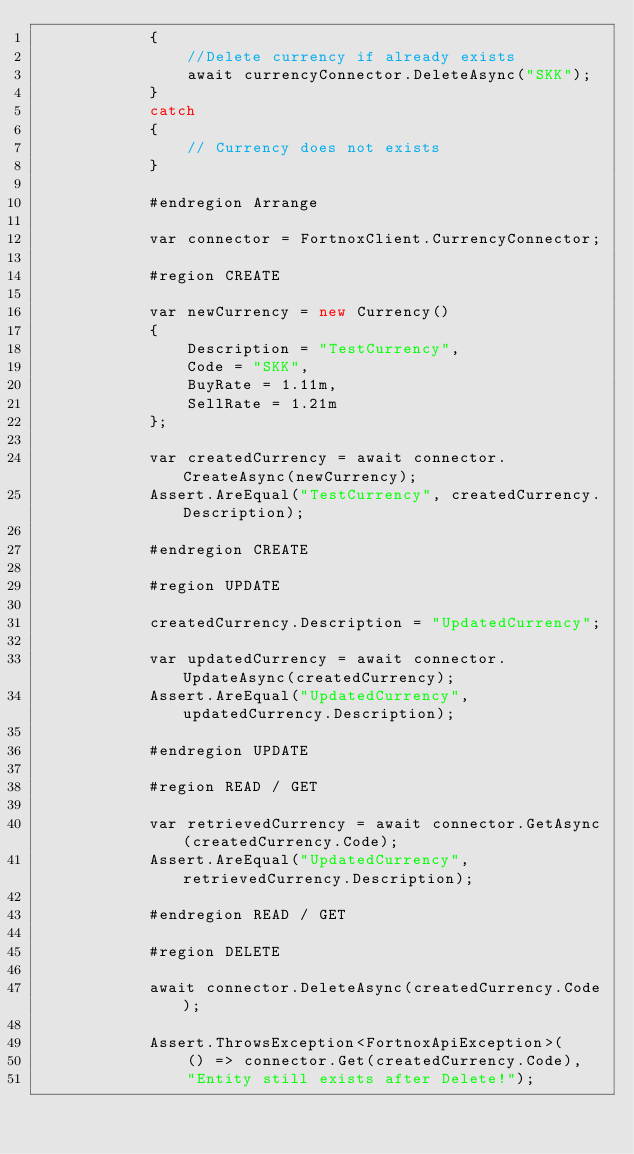Convert code to text. <code><loc_0><loc_0><loc_500><loc_500><_C#_>            {
                //Delete currency if already exists
                await currencyConnector.DeleteAsync("SKK");
            }
            catch
            {
                // Currency does not exists
            }

            #endregion Arrange

            var connector = FortnoxClient.CurrencyConnector;

            #region CREATE

            var newCurrency = new Currency()
            {
                Description = "TestCurrency",
                Code = "SKK",
                BuyRate = 1.11m,
                SellRate = 1.21m
            };

            var createdCurrency = await connector.CreateAsync(newCurrency);
            Assert.AreEqual("TestCurrency", createdCurrency.Description);

            #endregion CREATE

            #region UPDATE

            createdCurrency.Description = "UpdatedCurrency";

            var updatedCurrency = await connector.UpdateAsync(createdCurrency);
            Assert.AreEqual("UpdatedCurrency", updatedCurrency.Description);

            #endregion UPDATE

            #region READ / GET

            var retrievedCurrency = await connector.GetAsync(createdCurrency.Code);
            Assert.AreEqual("UpdatedCurrency", retrievedCurrency.Description);

            #endregion READ / GET

            #region DELETE

            await connector.DeleteAsync(createdCurrency.Code);

            Assert.ThrowsException<FortnoxApiException>(
                () => connector.Get(createdCurrency.Code),
                "Entity still exists after Delete!");
</code> 